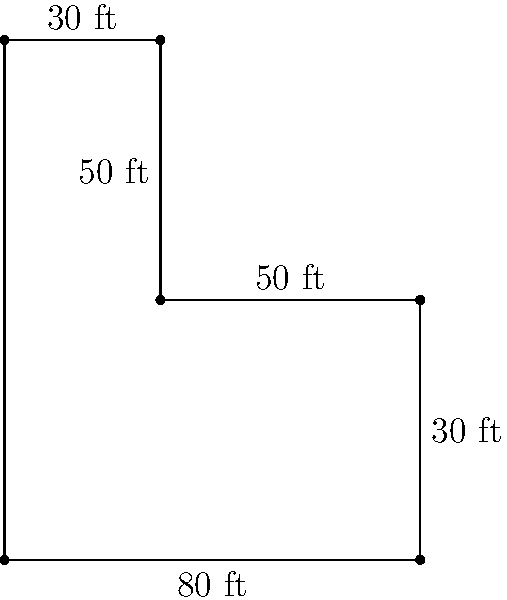You're discussing a unique home renovation project with a client who has an L-shaped living room. They've provided you with the dimensions as shown in the diagram. To help them budget for new flooring, you need to calculate the perimeter of this room. What is the total perimeter of the L-shaped room in feet? Let's approach this step-by-step, just as we would walk a client through understanding their mortgage terms:

1) First, let's identify all the sides of the room:
   - Left side: 100 ft
   - Bottom: 80 ft
   - Right side (split into two parts): 50 ft + 30 ft = 80 ft
   - Top (split into two parts): 30 ft + 50 ft = 80 ft

2) Now, let's add up all these sides:
   $$ \text{Perimeter} = 100 + 80 + 80 + 80 = 340 \text{ ft} $$

3) Double-check our work:
   - We've accounted for all visible sides in the diagram
   - Each side has been counted only once

Just as we ensure all details are correct in a mortgage application, we've carefully considered each part of this room's unique shape to arrive at our answer.
Answer: 340 ft 